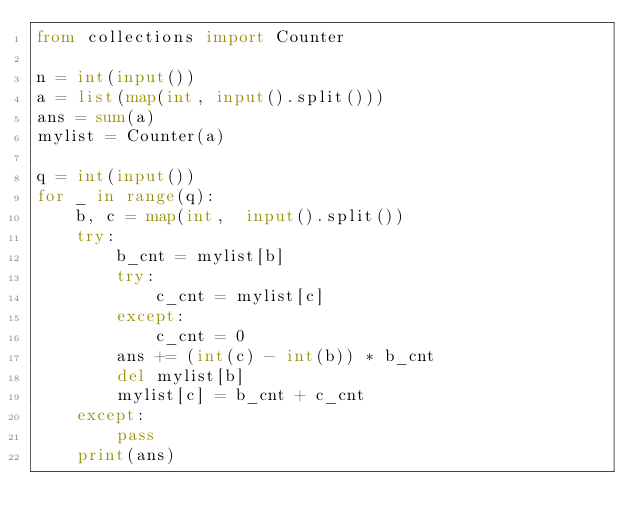Convert code to text. <code><loc_0><loc_0><loc_500><loc_500><_Python_>from collections import Counter

n = int(input())
a = list(map(int, input().split()))
ans = sum(a)
mylist = Counter(a)

q = int(input())
for _ in range(q):
    b, c = map(int,  input().split())
    try:
        b_cnt = mylist[b]
        try:
            c_cnt = mylist[c]
        except:
            c_cnt = 0
        ans += (int(c) - int(b)) * b_cnt
        del mylist[b]
        mylist[c] = b_cnt + c_cnt
    except:
        pass
    print(ans)
</code> 